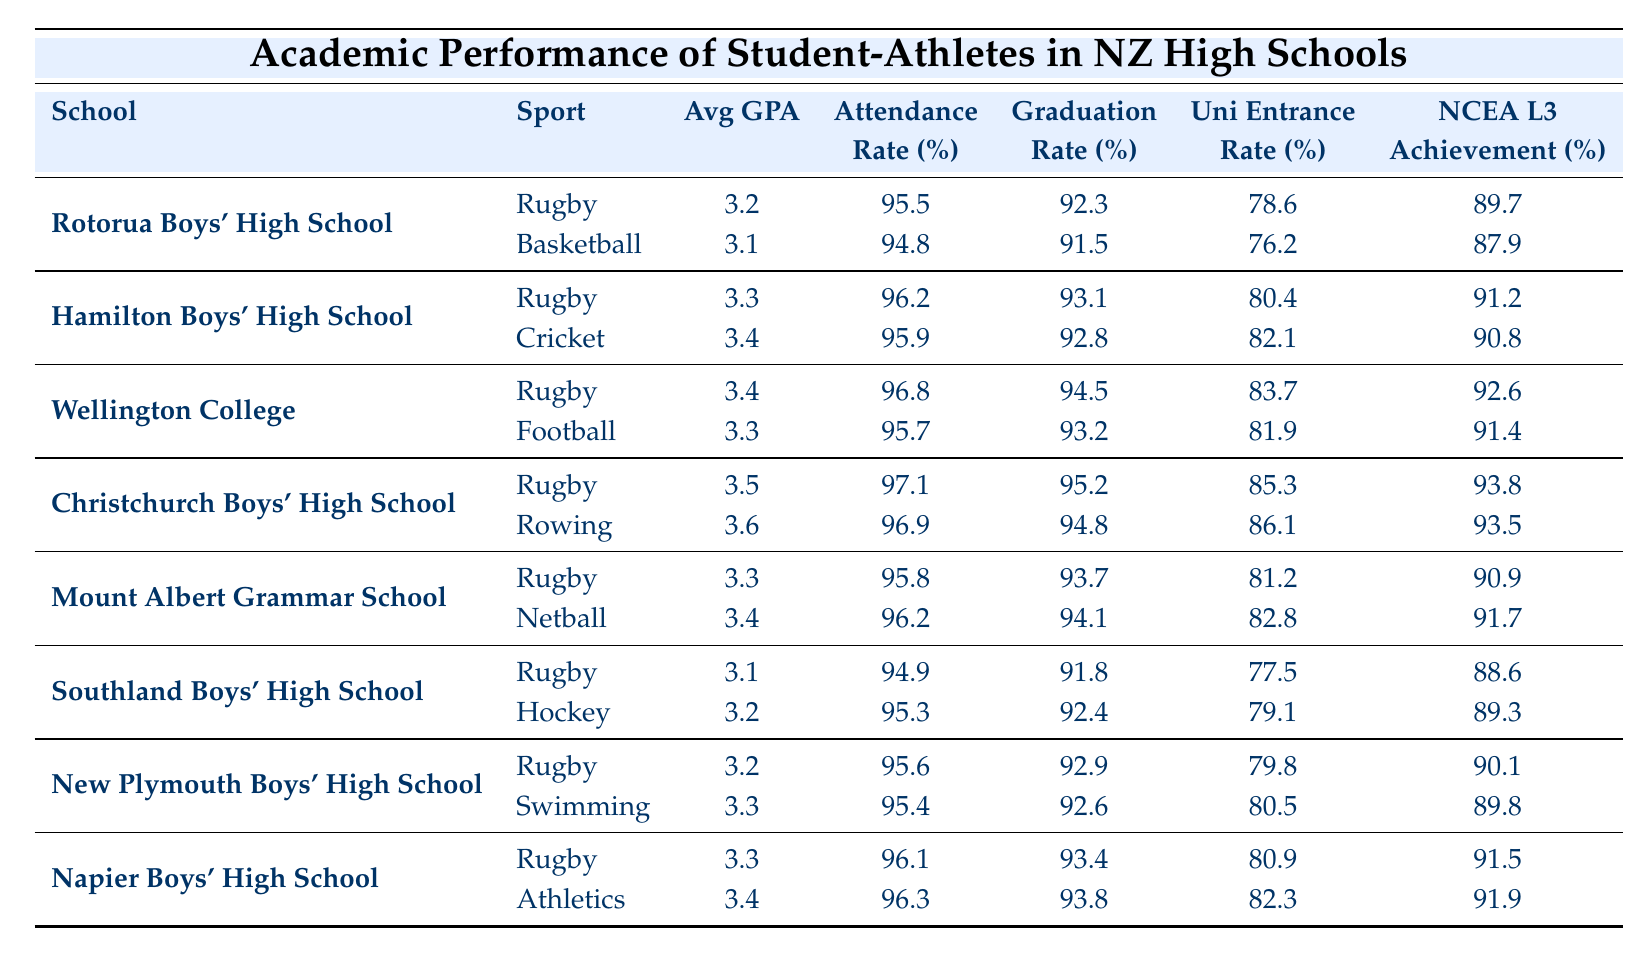What is the average GPA of rugby players at Christchurch Boys' High School? The data shows that the average GPA for rugby players at Christchurch Boys' High School is 3.5.
Answer: 3.5 Which school has the highest attendance rate for rugby players? Looking at the attendance rates of rugby players, Christchurch Boys' High School has the highest rate at 97.1%.
Answer: Christchurch Boys' High School Do rugby players at Rotorua Boys' High School have a higher graduation rate than basketball players? The rugby players have a graduation rate of 92.3%, while basketball players have a graduation rate of 91.5%. Thus, rugby players do have a higher graduation rate.
Answer: Yes What is the difference in NCEA Level 3 achievement rates between rugby players at Hamilton Boys' High School and cricket players? The NCEA Level 3 achievement rate for rugby players is 91.2%, and for cricket players, it is 90.8%. The difference is 91.2% - 90.8% = 0.4%.
Answer: 0.4% Which sport has a better average GPA overall, rugby or netball? To compare, we take the average GPA of rugby players (3.2 + 3.3 + 3.4 + 3.5 + 3.3 + 3.1 + 3.2 + 3.3 = 26.2) and divide by the 8 rugby data points, giving us an average of 3.275. The average GPA for netball (just one entry with 3.4 from Mount Albert Grammar School) is 3.4. Since 3.275 < 3.4, netball has a better GPA.
Answer: Netball What percentage of rugby players at Wellington College graduated? The graduation rate for rugby players at Wellington College is 94.5%.
Answer: 94.5% Is the average GPA of rugby players from New Plymouth Boys' High School the same as that of swimming players? The average GPA for rugby players at New Plymouth Boys' High School is 3.2, while swimming players have an average GPA of 3.3, so they are not the same.
Answer: No Which sport has the lowest attendance rate among all listed sports? By comparing attendance rates across all sports, rugby players at Southland Boys' High School have the lowest attendance at 94.9%.
Answer: Rugby at Southland Boys' High School Calculate the difference in university entrance rates between rugby players and football players at Wellington College. The university entrance rate for rugby players at Wellington College is 83.7%, while for football players, it is 81.9%. Therefore, the difference is 83.7% - 81.9% = 1.8%.
Answer: 1.8% Which high school has the highest university entrance rate among rugby players? The university entrance rate for rugby players at Christchurch Boys' High School is 85.3%, which is the highest compared to other schools.
Answer: Christchurch Boys' High School What is the average NCEA Level 3 achievement rate for rugby players across all high schools? The average NCEA Level 3 achievement rates for rugby players are (89.7 + 91.2 + 92.6 + 93.8 + 90.9 + 88.6 + 90.1 + 91.5) = 719.4, and dividing by 8 gives 89.925.
Answer: 89.93 